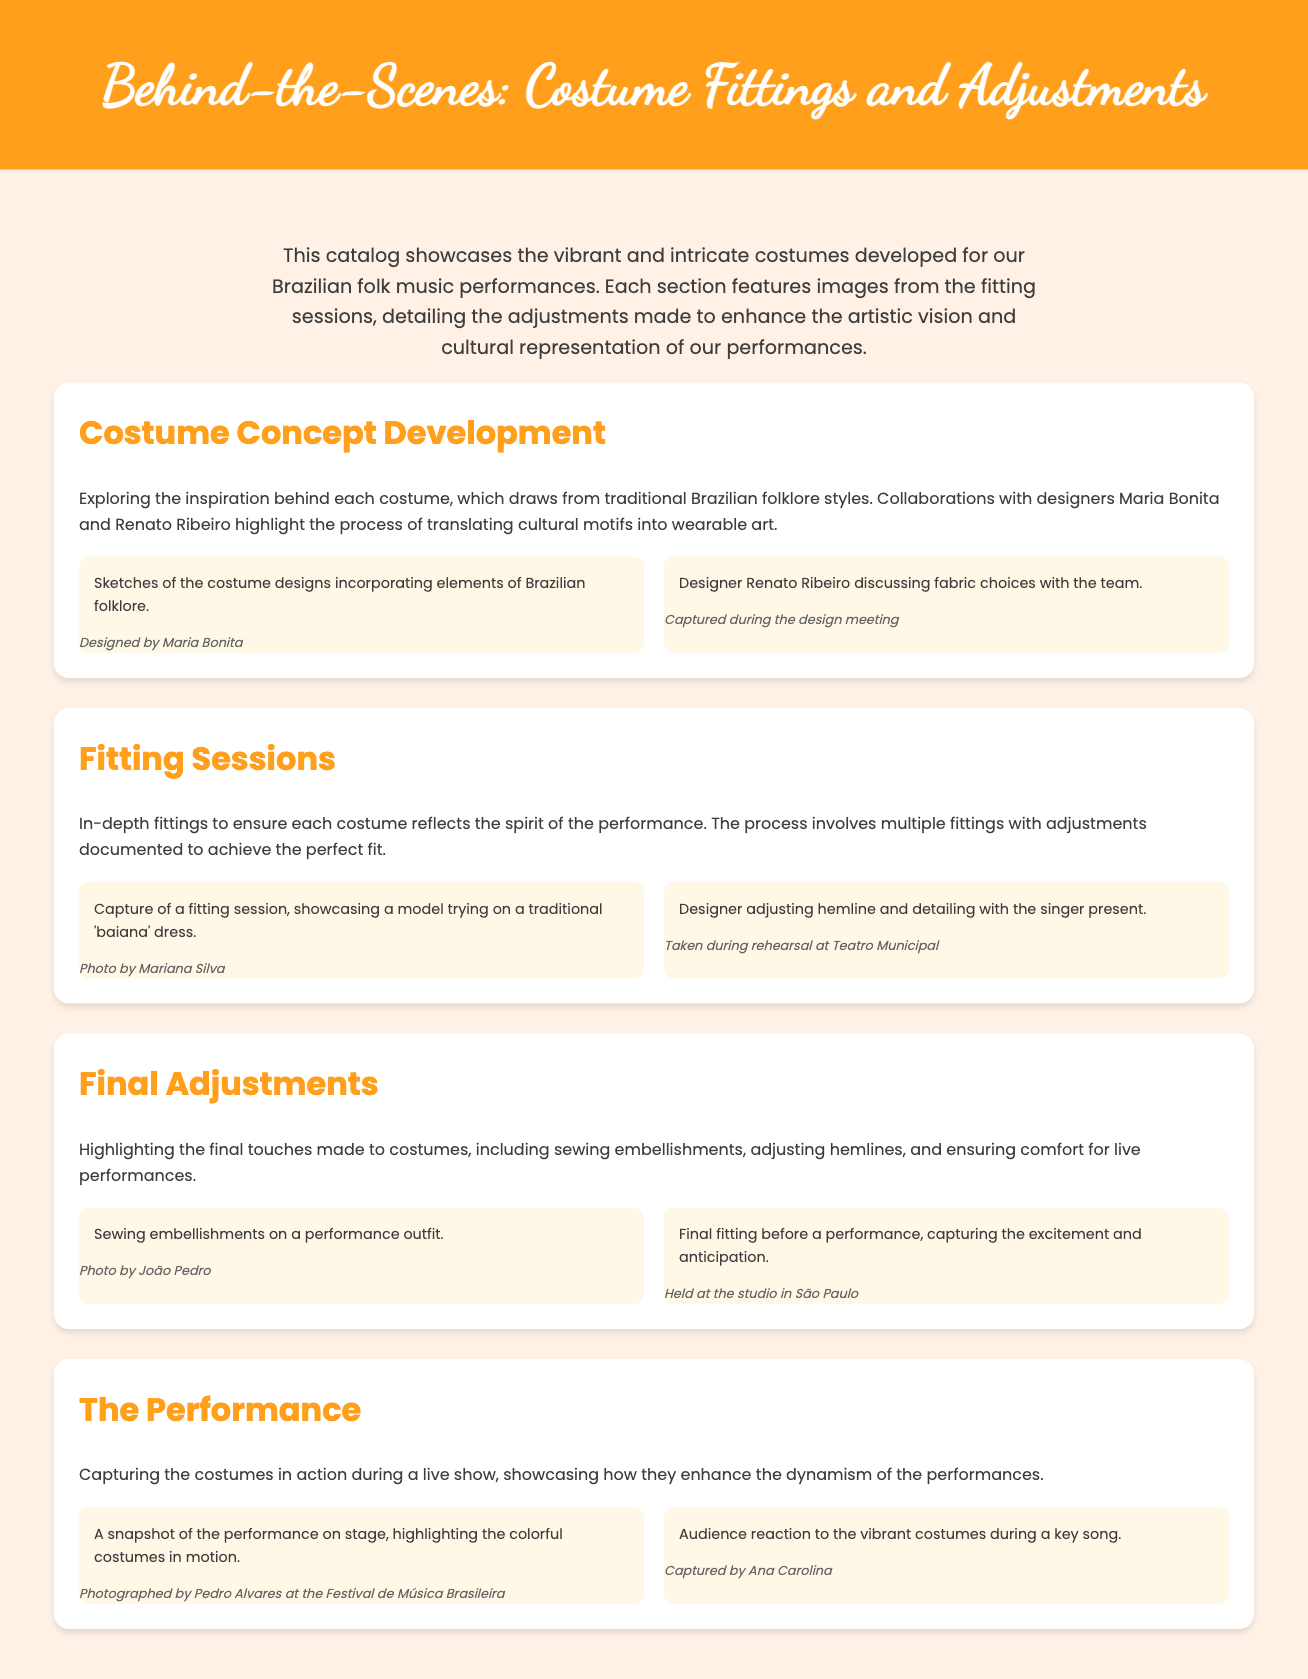What is the title of the catalog? The title is prominently displayed in the header section of the document.
Answer: Behind-the-Scenes: Costume Fittings and Adjustments Who collaborated with Maria Bonita on the costume designs? The document mentions a collaboration for costume designs, highlighting another designer.
Answer: Renato Ribeiro What type of dress is featured in the fitting session? The document specifies the kind of traditional clothing being tried on during the fitting session.
Answer: 'Baiana' dress Where was the rehearsal for costume adjustments held? The document provides a location where the adjustments and fittings took place.
Answer: Teatro Municipal What is highlighted during the final adjustments section? This section details specific actions taken to enhance the costumes right before performances.
Answer: Sewing embellishments Who captured the photo of the final fitting? The document credits the photographer for capturing an important moment in the fitting process.
Answer: João Pedro What type of performance is showcased in this catalog? The document specifically refers to the kind of events at which the costumes are worn.
Answer: Live show What was the audience's reaction captured during a performance? The document describes a specific aspect of audience engagement during the show.
Answer: Vibrant costumes 